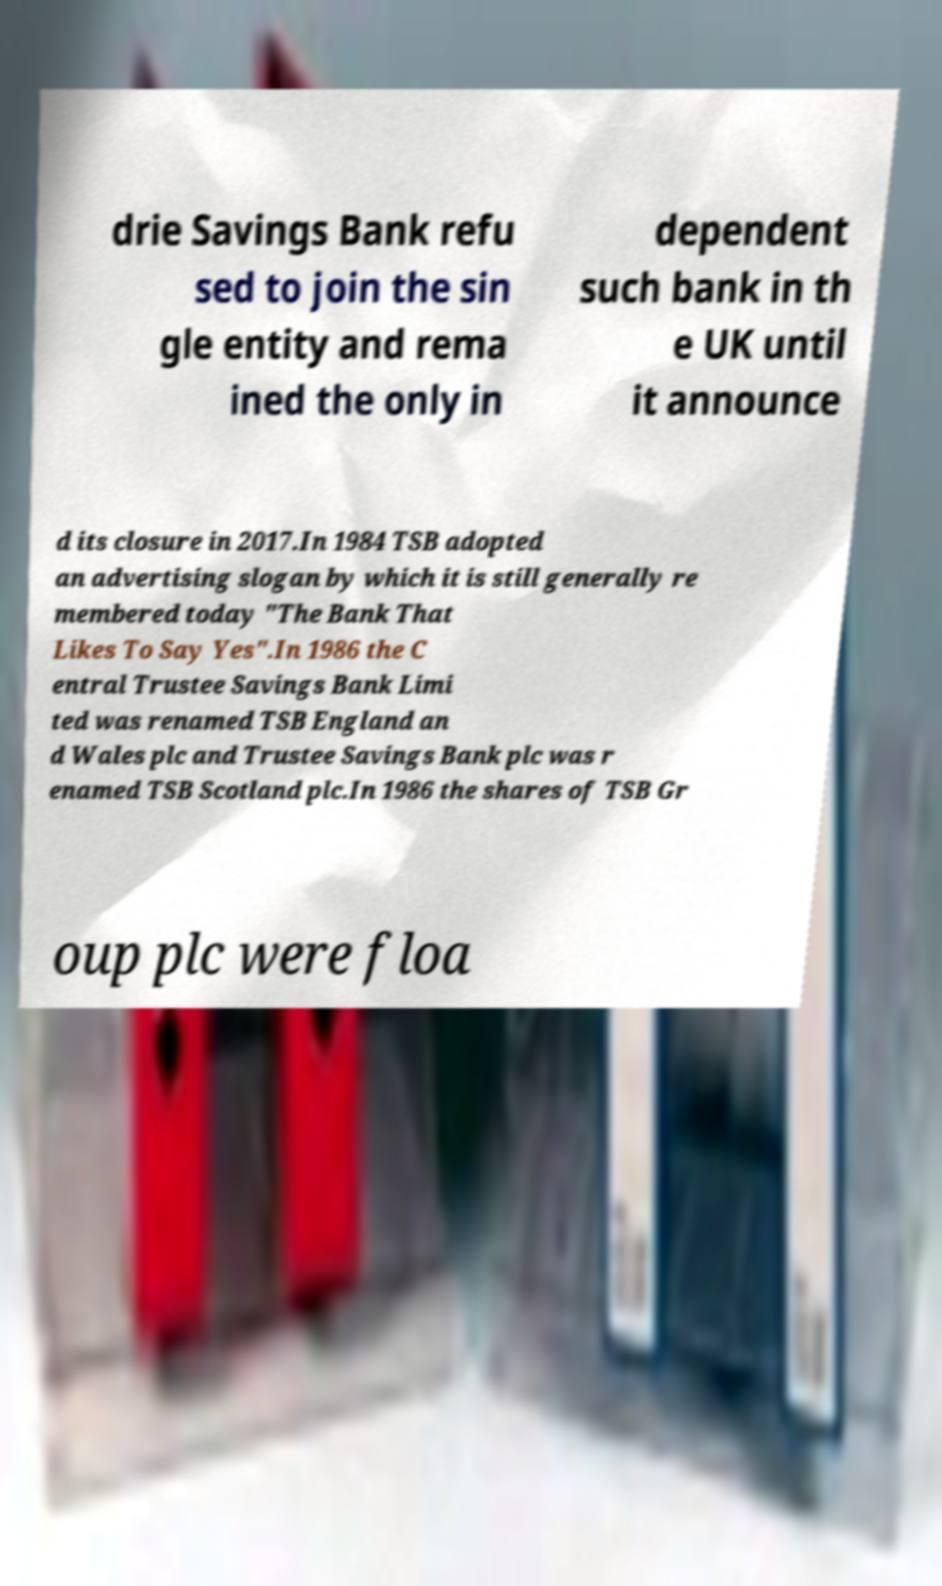Can you accurately transcribe the text from the provided image for me? drie Savings Bank refu sed to join the sin gle entity and rema ined the only in dependent such bank in th e UK until it announce d its closure in 2017.In 1984 TSB adopted an advertising slogan by which it is still generally re membered today "The Bank That Likes To Say Yes".In 1986 the C entral Trustee Savings Bank Limi ted was renamed TSB England an d Wales plc and Trustee Savings Bank plc was r enamed TSB Scotland plc.In 1986 the shares of TSB Gr oup plc were floa 